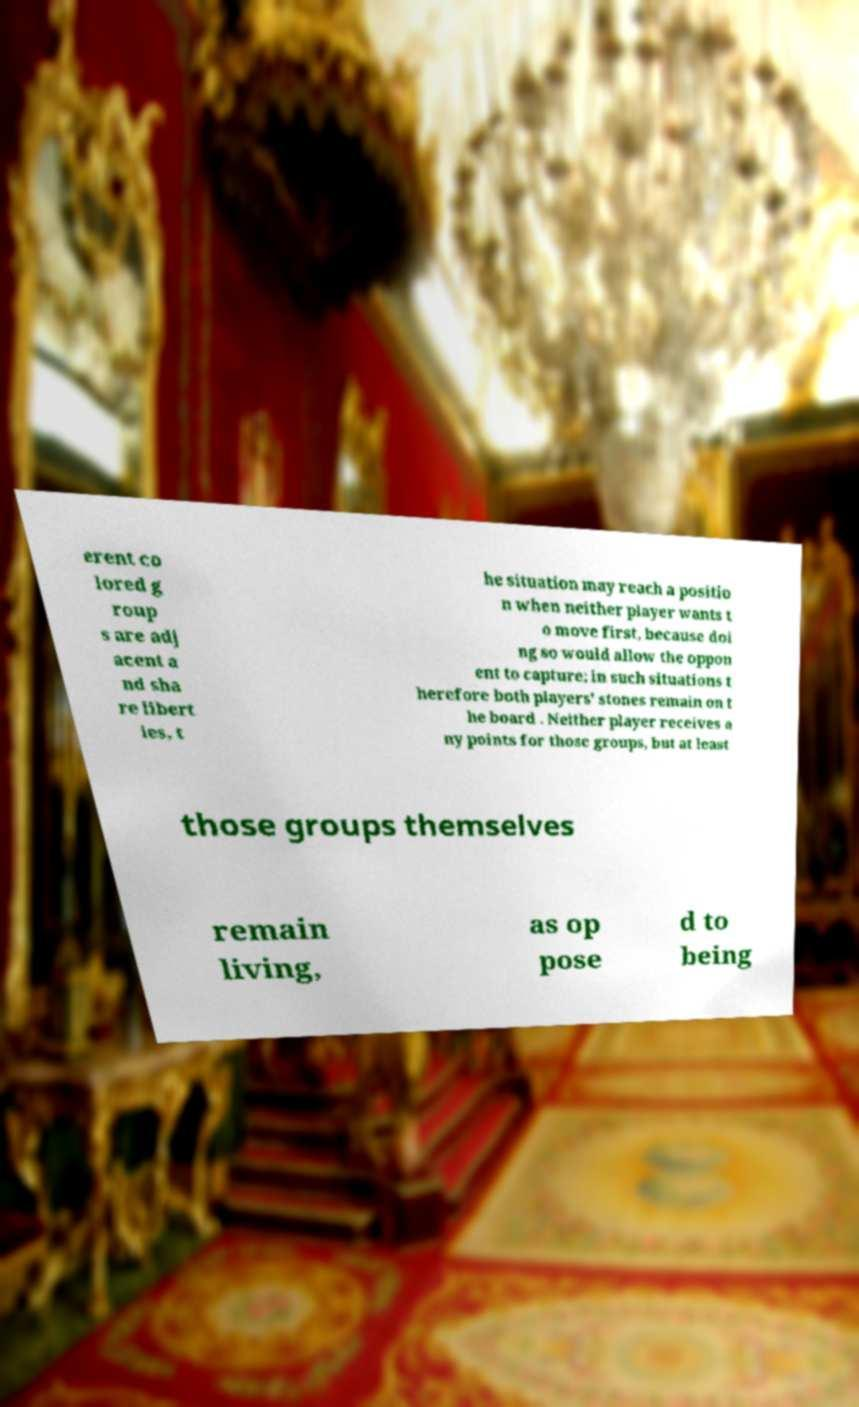Please identify and transcribe the text found in this image. erent co lored g roup s are adj acent a nd sha re libert ies, t he situation may reach a positio n when neither player wants t o move first, because doi ng so would allow the oppon ent to capture; in such situations t herefore both players' stones remain on t he board . Neither player receives a ny points for those groups, but at least those groups themselves remain living, as op pose d to being 